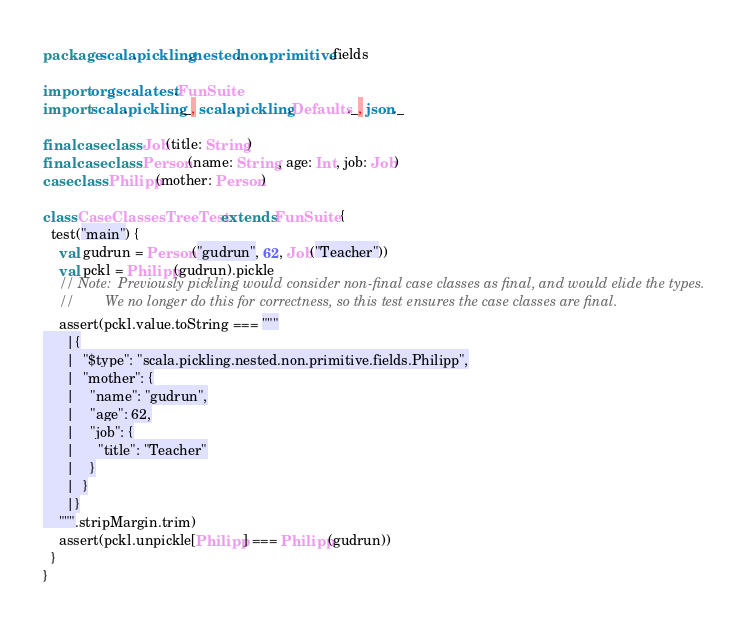Convert code to text. <code><loc_0><loc_0><loc_500><loc_500><_Scala_>package scala.pickling.nested.non.primitive.fields

import org.scalatest.FunSuite
import scala.pickling._, scala.pickling.Defaults._, json._

final case class Job(title: String)
final case class Person(name: String, age: Int, job: Job)
case class Philipp(mother: Person)

class CaseClassesTreeTest extends FunSuite {
  test("main") {
    val gudrun = Person("gudrun", 62, Job("Teacher"))
    val pckl = Philipp(gudrun).pickle
    // Note:  Previously pickling would consider non-final case classes as final, and would elide the types.
    //        We no longer do this for correctness, so this test ensures the case classes are final.
    assert(pckl.value.toString === """
      |{
      |  "$type": "scala.pickling.nested.non.primitive.fields.Philipp",
      |  "mother": {
      |    "name": "gudrun",
      |    "age": 62,
      |    "job": {
      |      "title": "Teacher"
      |    }
      |  }
      |}
    """.stripMargin.trim)
    assert(pckl.unpickle[Philipp] === Philipp(gudrun))
  }
}
</code> 